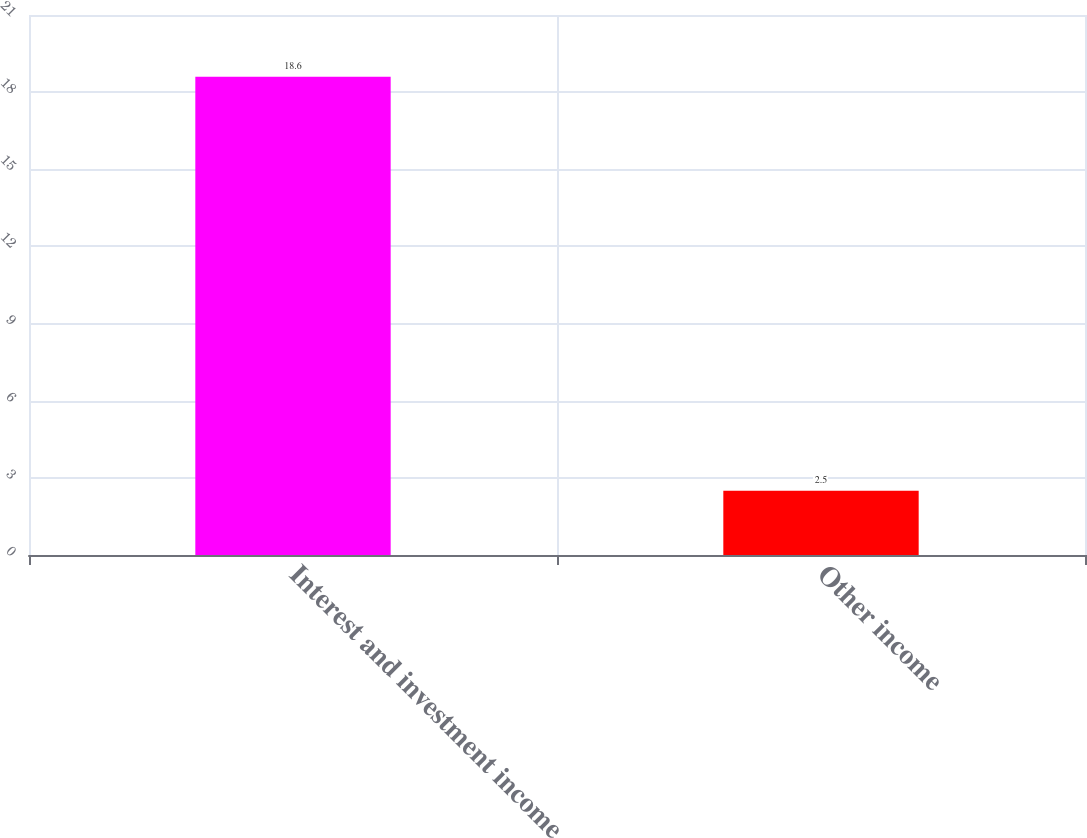Convert chart to OTSL. <chart><loc_0><loc_0><loc_500><loc_500><bar_chart><fcel>Interest and investment income<fcel>Other income<nl><fcel>18.6<fcel>2.5<nl></chart> 